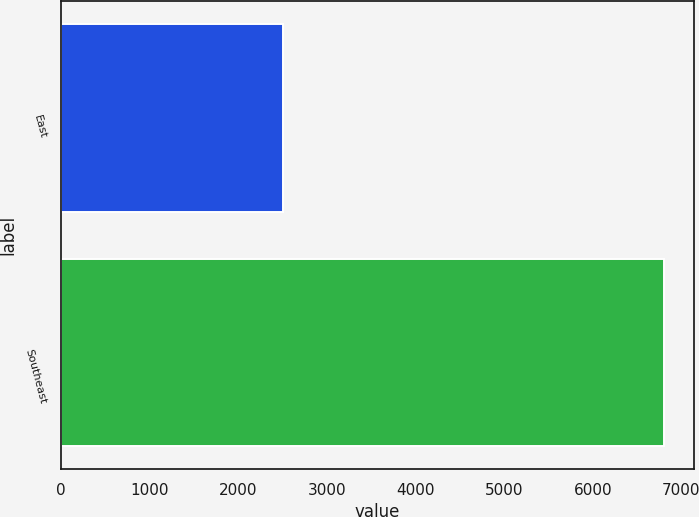<chart> <loc_0><loc_0><loc_500><loc_500><bar_chart><fcel>East<fcel>Southeast<nl><fcel>2505<fcel>6807<nl></chart> 